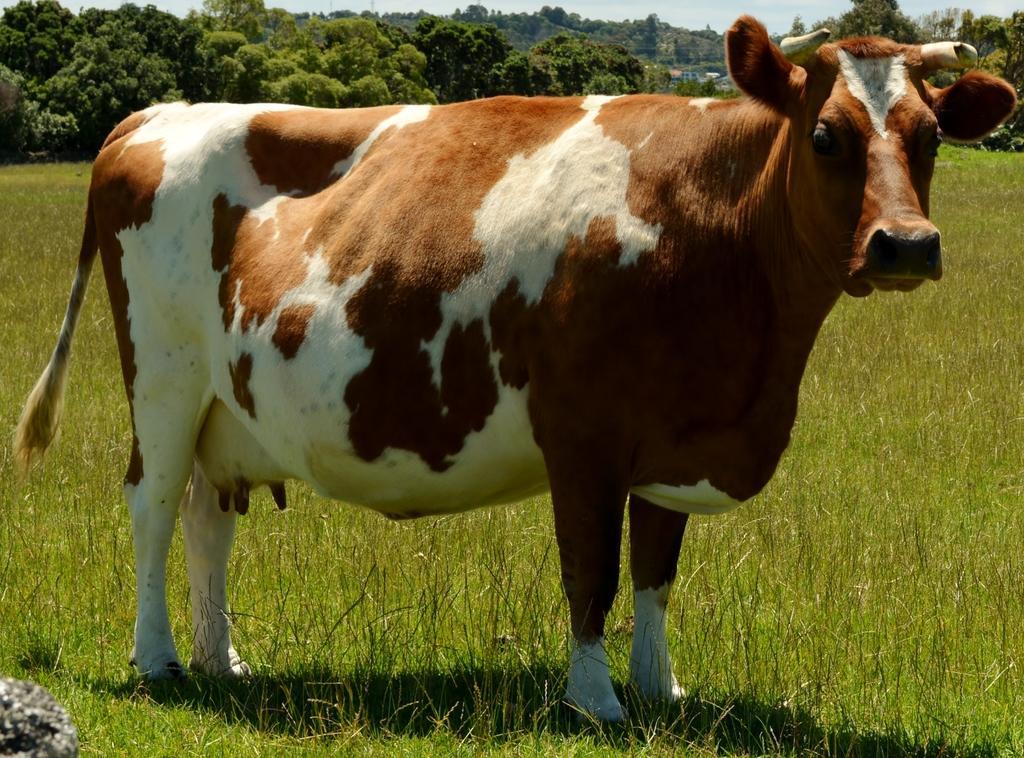In one or two sentences, can you explain what this image depicts? In this picture there is a cow standing on the grass. At the back there are trees. At the top there is sky. At the bottom there is grass. 